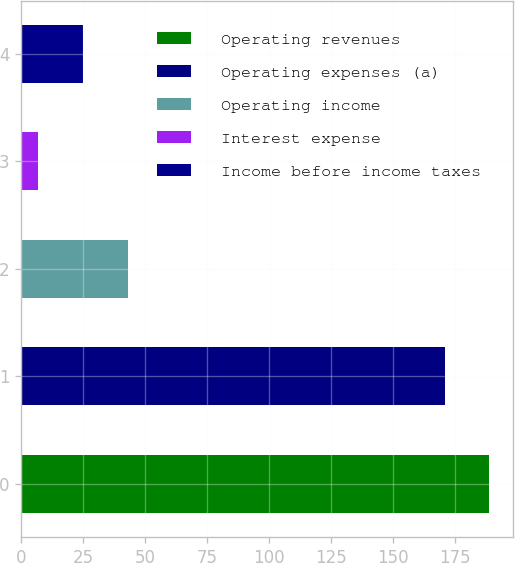Convert chart to OTSL. <chart><loc_0><loc_0><loc_500><loc_500><bar_chart><fcel>Operating revenues<fcel>Operating expenses (a)<fcel>Operating income<fcel>Interest expense<fcel>Income before income taxes<nl><fcel>189<fcel>171<fcel>43<fcel>7<fcel>25<nl></chart> 